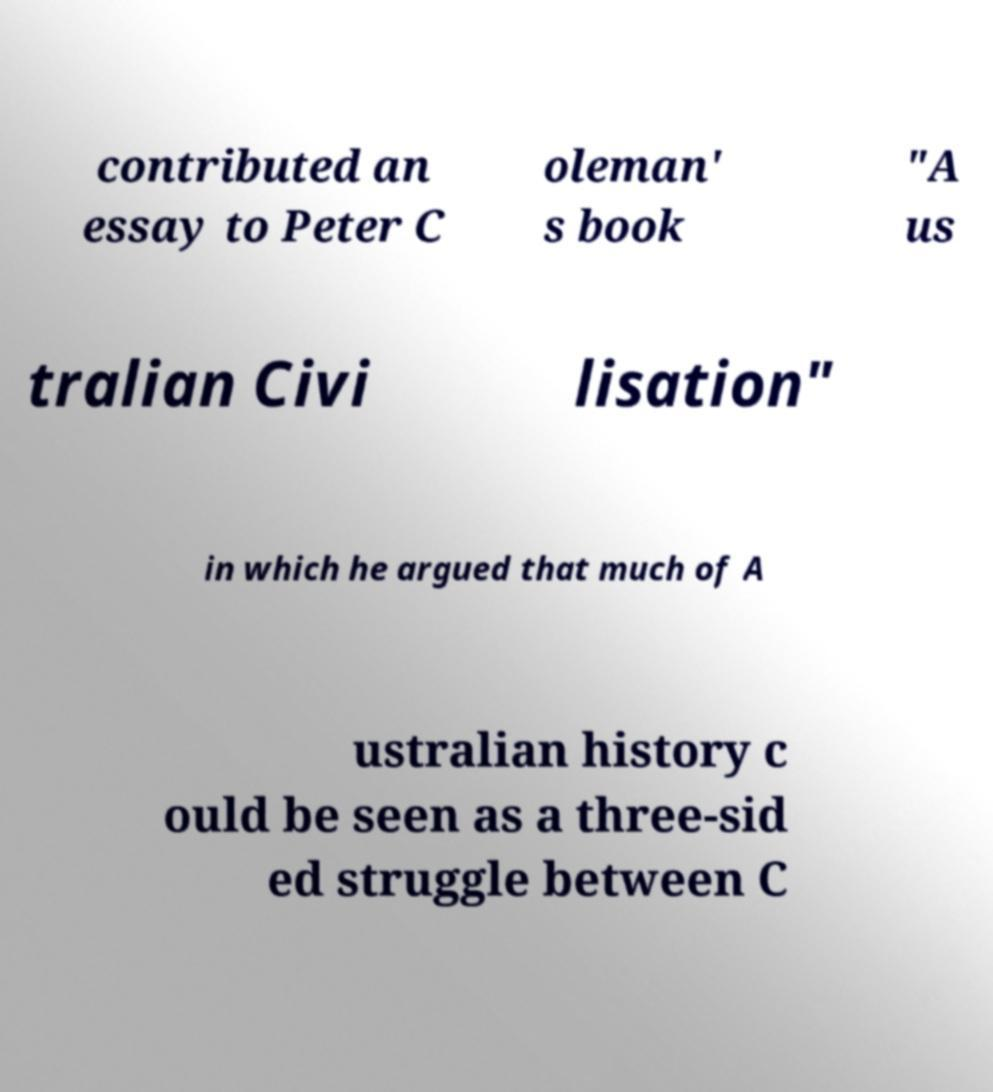For documentation purposes, I need the text within this image transcribed. Could you provide that? contributed an essay to Peter C oleman' s book "A us tralian Civi lisation" in which he argued that much of A ustralian history c ould be seen as a three-sid ed struggle between C 